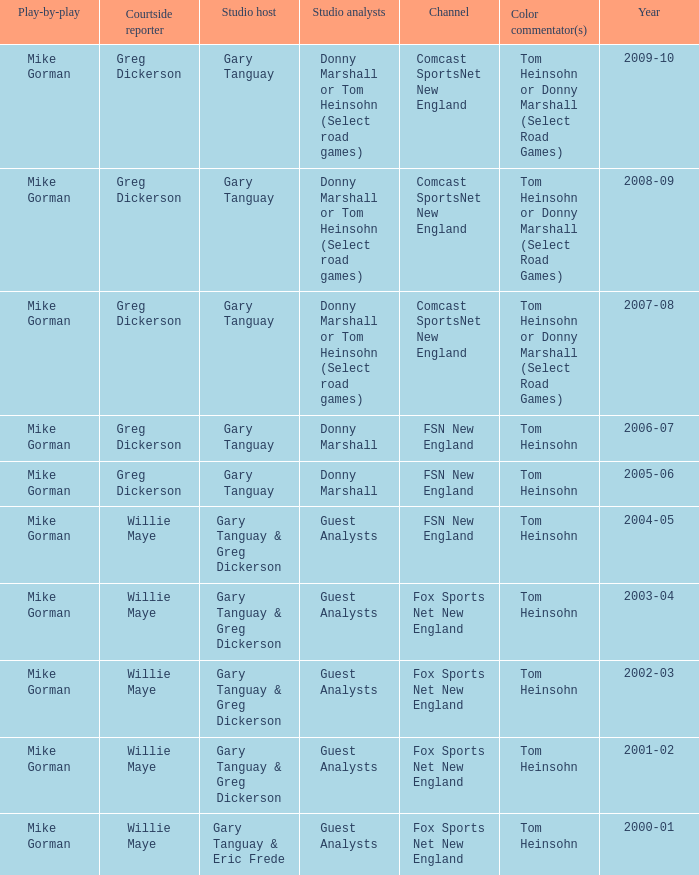WHich Play-by-play has a Studio host of gary tanguay, and a Studio analysts of donny marshall? Mike Gorman, Mike Gorman. 